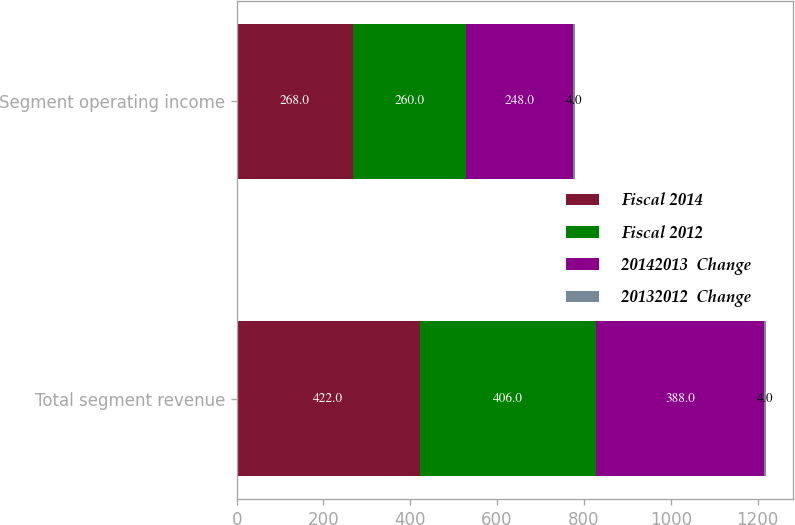<chart> <loc_0><loc_0><loc_500><loc_500><stacked_bar_chart><ecel><fcel>Total segment revenue<fcel>Segment operating income<nl><fcel>Fiscal 2014<fcel>422<fcel>268<nl><fcel>Fiscal 2012<fcel>406<fcel>260<nl><fcel>20142013  Change<fcel>388<fcel>248<nl><fcel>20132012  Change<fcel>4<fcel>4<nl></chart> 